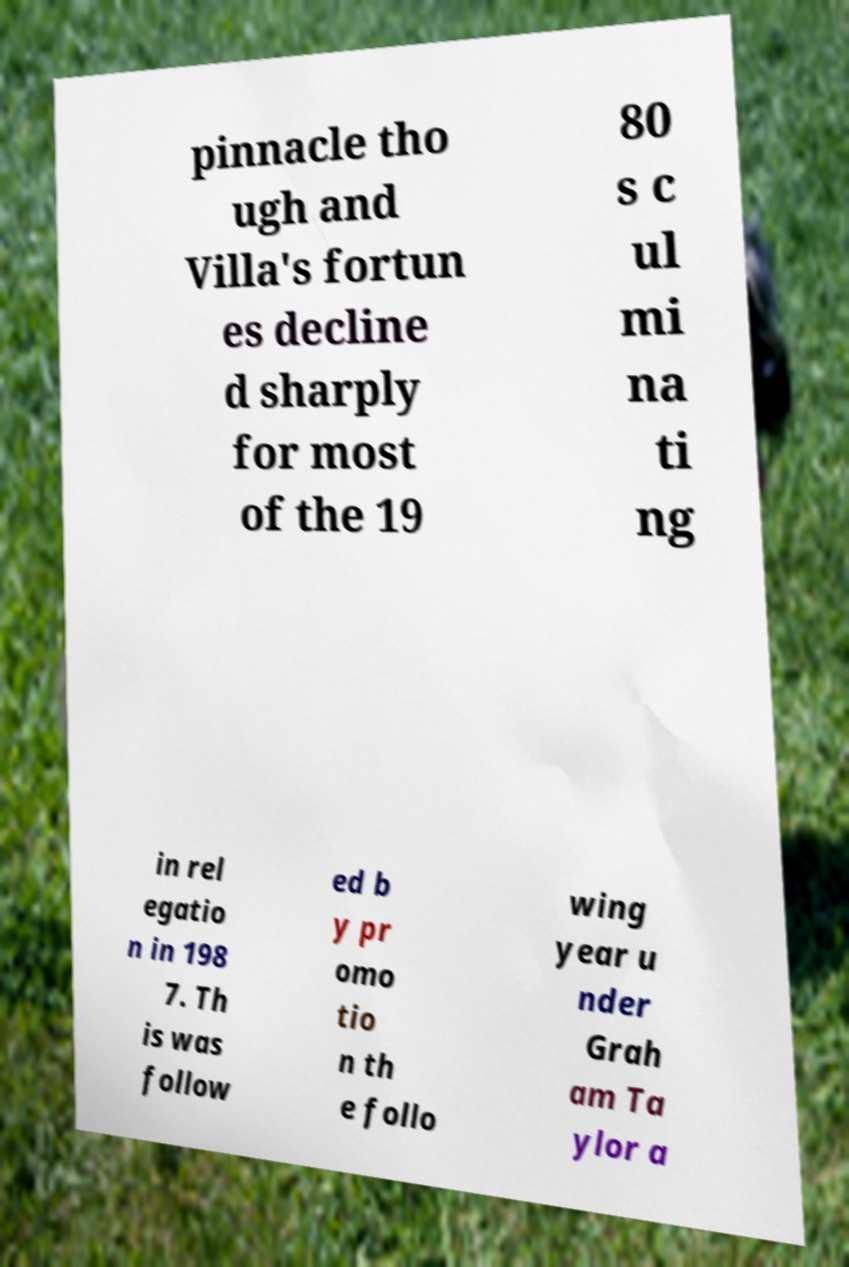There's text embedded in this image that I need extracted. Can you transcribe it verbatim? pinnacle tho ugh and Villa's fortun es decline d sharply for most of the 19 80 s c ul mi na ti ng in rel egatio n in 198 7. Th is was follow ed b y pr omo tio n th e follo wing year u nder Grah am Ta ylor a 